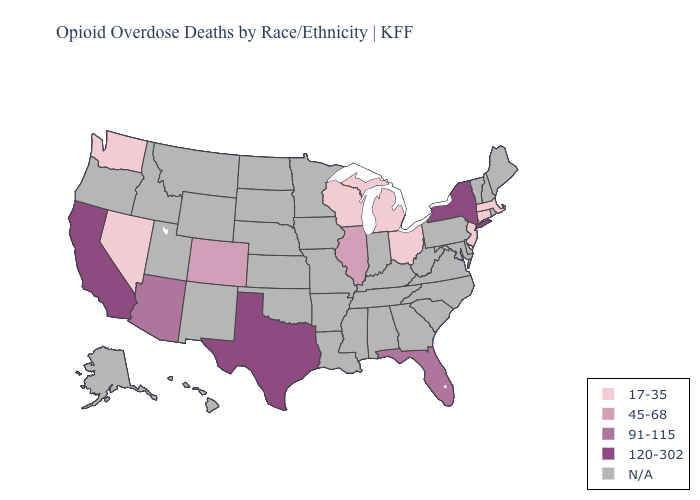Which states have the lowest value in the Northeast?
Give a very brief answer. Connecticut, Massachusetts, New Jersey. What is the value of Montana?
Short answer required. N/A. Does Connecticut have the highest value in the USA?
Be succinct. No. What is the highest value in states that border Louisiana?
Write a very short answer. 120-302. What is the value of Florida?
Keep it brief. 91-115. Name the states that have a value in the range 17-35?
Give a very brief answer. Connecticut, Massachusetts, Michigan, Nevada, New Jersey, Ohio, Washington, Wisconsin. Among the states that border Minnesota , which have the lowest value?
Answer briefly. Wisconsin. What is the highest value in the South ?
Answer briefly. 120-302. Which states have the lowest value in the USA?
Be succinct. Connecticut, Massachusetts, Michigan, Nevada, New Jersey, Ohio, Washington, Wisconsin. Among the states that border Pennsylvania , which have the lowest value?
Short answer required. New Jersey, Ohio. Does Florida have the lowest value in the USA?
Concise answer only. No. Name the states that have a value in the range N/A?
Quick response, please. Alabama, Alaska, Arkansas, Delaware, Georgia, Hawaii, Idaho, Indiana, Iowa, Kansas, Kentucky, Louisiana, Maine, Maryland, Minnesota, Mississippi, Missouri, Montana, Nebraska, New Hampshire, New Mexico, North Carolina, North Dakota, Oklahoma, Oregon, Pennsylvania, Rhode Island, South Carolina, South Dakota, Tennessee, Utah, Vermont, Virginia, West Virginia, Wyoming. Which states hav the highest value in the South?
Concise answer only. Texas. Is the legend a continuous bar?
Quick response, please. No. 